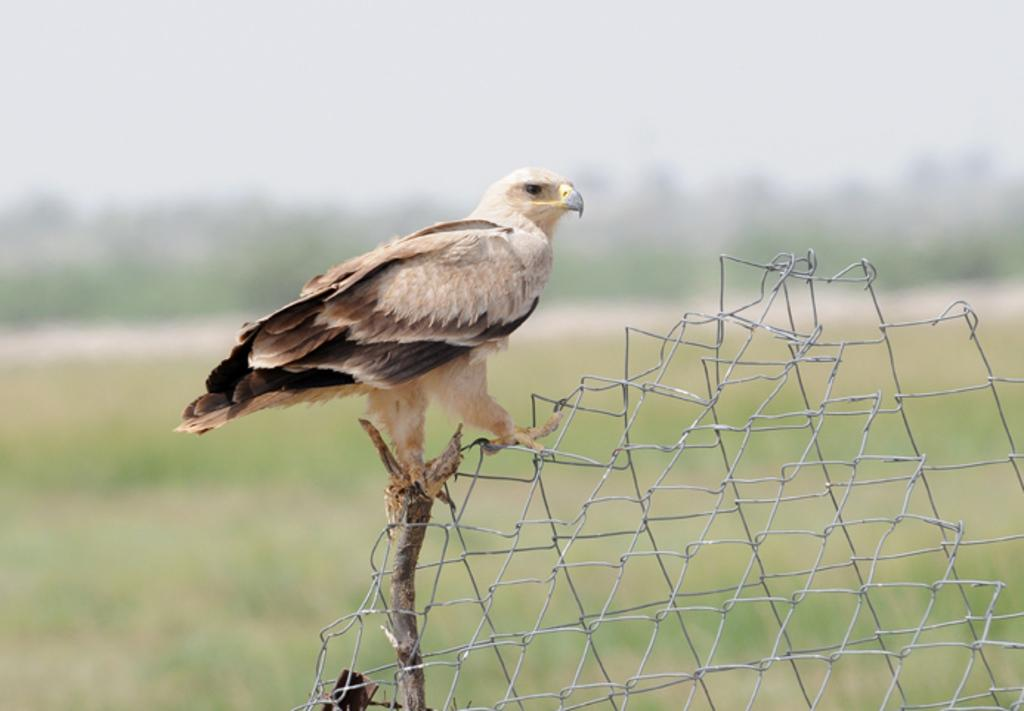What is on the metal fence in the image? There is a bird on a metal fence in the image. What type of surface is at the bottom of the image? There is grass on the surface at the bottom of the image. What can be seen in the background of the image? There are trees and the sky visible in the background of the image. What type of pickle is being used to control the bird in the image? There is no pickle or any attempt to control the bird in the image; the bird is simply perched on the metal fence. 